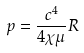Convert formula to latex. <formula><loc_0><loc_0><loc_500><loc_500>p = \frac { c ^ { 4 } } { 4 \chi \mu } R</formula> 